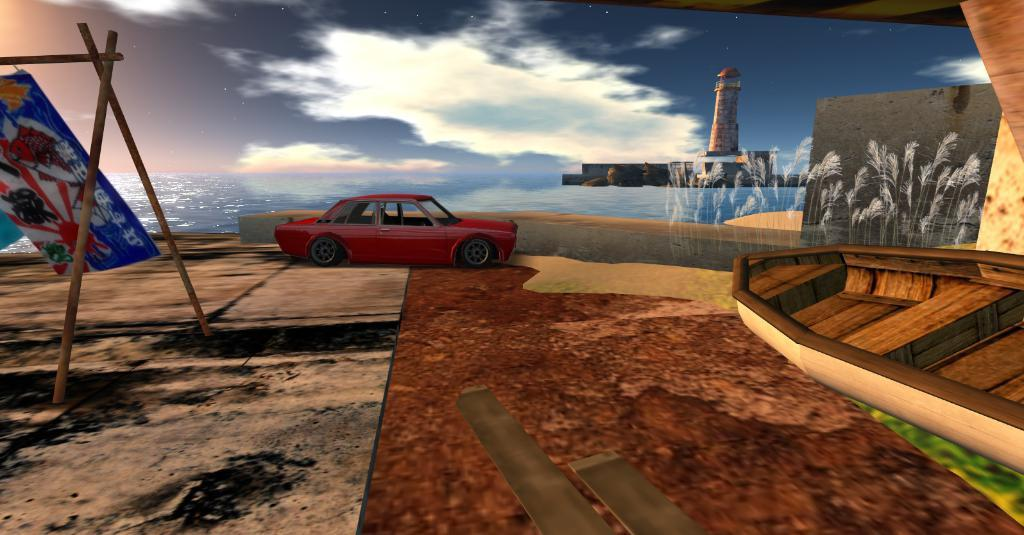What type of picture is the image? The image is an animated picture. What mode of transportation can be seen in the image? There is a car in the image. What is the purpose of the banner in the image? The purpose of the banner is not specified in the image. What objects are made of wood in the image? There are wooden sticks in the image. What type of watercraft is present in the image? There is a boat in the image. What is the nature of the water visible in the image? The water is not specified as a stream or any other type in the image. What tall structure is present in the image? There is a tower in the image. What is visible in the background of the image? The sky with clouds is visible in the background of the image. What type of parent is depicted in the image? There is no parent depicted in the image. What is the best way to cross the stream in the image? There is no stream present in the image, so there is no need to find a way to cross it. 